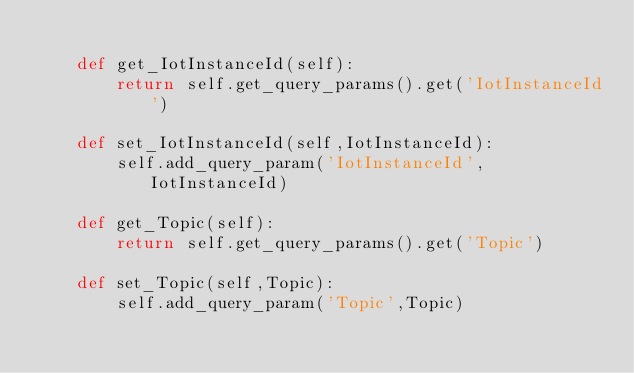Convert code to text. <code><loc_0><loc_0><loc_500><loc_500><_Python_>
	def get_IotInstanceId(self):
		return self.get_query_params().get('IotInstanceId')

	def set_IotInstanceId(self,IotInstanceId):
		self.add_query_param('IotInstanceId',IotInstanceId)

	def get_Topic(self):
		return self.get_query_params().get('Topic')

	def set_Topic(self,Topic):
		self.add_query_param('Topic',Topic)</code> 